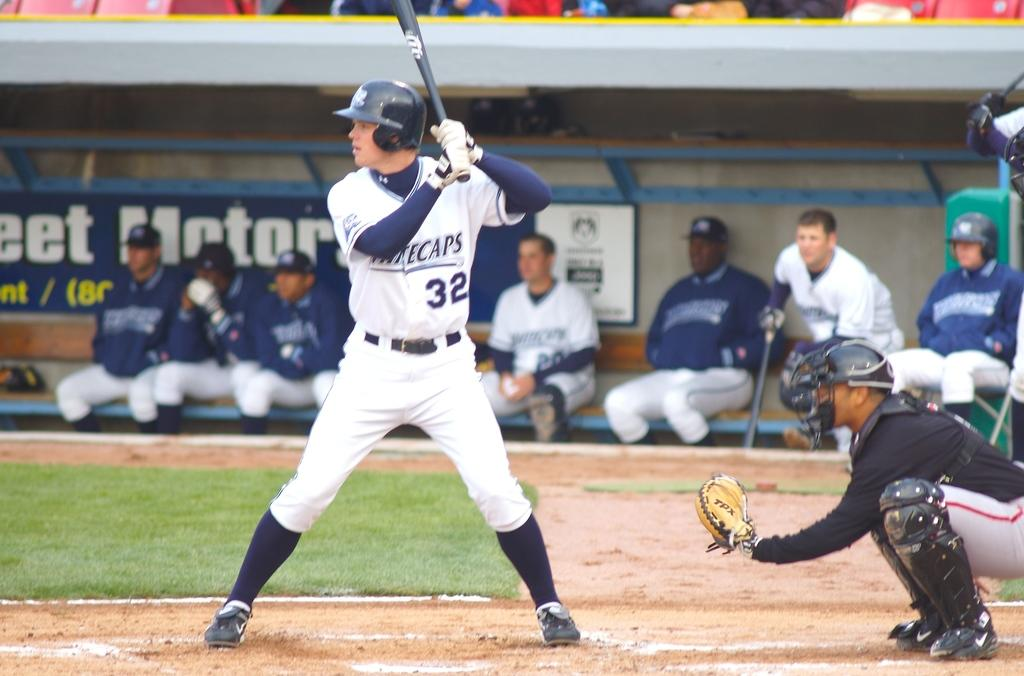<image>
Present a compact description of the photo's key features. A baseball player numbered 32 and with Whitecaps on his top prepares to bat as other players look on. 